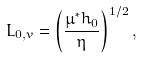Convert formula to latex. <formula><loc_0><loc_0><loc_500><loc_500>L _ { 0 , v } = \left ( \frac { \mu ^ { * } h _ { 0 } } { \eta } \right ) ^ { 1 / 2 } ,</formula> 